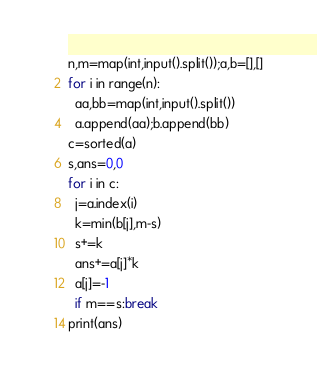<code> <loc_0><loc_0><loc_500><loc_500><_Python_>n,m=map(int,input().split());a,b=[],[]
for i in range(n):
  aa,bb=map(int,input().split())
  a.append(aa);b.append(bb)
c=sorted(a)
s,ans=0,0
for i in c:
  j=a.index(i)
  k=min(b[j],m-s)
  s+=k
  ans+=a[j]*k
  a[j]=-1
  if m==s:break
print(ans)</code> 